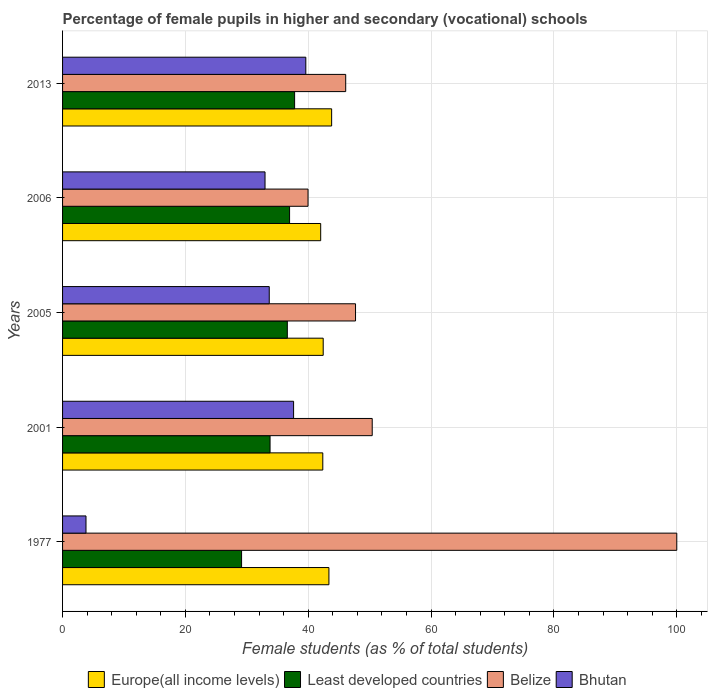Are the number of bars per tick equal to the number of legend labels?
Provide a succinct answer. Yes. What is the label of the 2nd group of bars from the top?
Ensure brevity in your answer.  2006. What is the percentage of female pupils in higher and secondary schools in Bhutan in 2006?
Provide a succinct answer. 32.96. Across all years, what is the maximum percentage of female pupils in higher and secondary schools in Europe(all income levels)?
Your answer should be compact. 43.81. Across all years, what is the minimum percentage of female pupils in higher and secondary schools in Bhutan?
Your response must be concise. 3.81. What is the total percentage of female pupils in higher and secondary schools in Belize in the graph?
Your answer should be compact. 284.17. What is the difference between the percentage of female pupils in higher and secondary schools in Bhutan in 1977 and that in 2006?
Provide a short and direct response. -29.15. What is the difference between the percentage of female pupils in higher and secondary schools in Bhutan in 1977 and the percentage of female pupils in higher and secondary schools in Belize in 2013?
Make the answer very short. -42.28. What is the average percentage of female pupils in higher and secondary schools in Bhutan per year?
Offer a terse response. 29.53. In the year 2013, what is the difference between the percentage of female pupils in higher and secondary schools in Europe(all income levels) and percentage of female pupils in higher and secondary schools in Belize?
Offer a very short reply. -2.29. What is the ratio of the percentage of female pupils in higher and secondary schools in Least developed countries in 1977 to that in 2006?
Ensure brevity in your answer.  0.79. Is the percentage of female pupils in higher and secondary schools in Bhutan in 2005 less than that in 2013?
Your answer should be very brief. Yes. What is the difference between the highest and the second highest percentage of female pupils in higher and secondary schools in Europe(all income levels)?
Offer a very short reply. 0.44. What is the difference between the highest and the lowest percentage of female pupils in higher and secondary schools in Least developed countries?
Your response must be concise. 8.63. Is it the case that in every year, the sum of the percentage of female pupils in higher and secondary schools in Least developed countries and percentage of female pupils in higher and secondary schools in Europe(all income levels) is greater than the sum of percentage of female pupils in higher and secondary schools in Bhutan and percentage of female pupils in higher and secondary schools in Belize?
Keep it short and to the point. No. What does the 1st bar from the top in 1977 represents?
Provide a short and direct response. Bhutan. What does the 3rd bar from the bottom in 2001 represents?
Offer a terse response. Belize. Is it the case that in every year, the sum of the percentage of female pupils in higher and secondary schools in Bhutan and percentage of female pupils in higher and secondary schools in Europe(all income levels) is greater than the percentage of female pupils in higher and secondary schools in Belize?
Offer a terse response. No. How many years are there in the graph?
Your answer should be compact. 5. What is the difference between two consecutive major ticks on the X-axis?
Ensure brevity in your answer.  20. Are the values on the major ticks of X-axis written in scientific E-notation?
Offer a very short reply. No. Does the graph contain any zero values?
Your answer should be very brief. No. Does the graph contain grids?
Offer a terse response. Yes. Where does the legend appear in the graph?
Give a very brief answer. Bottom center. What is the title of the graph?
Your response must be concise. Percentage of female pupils in higher and secondary (vocational) schools. Does "Cambodia" appear as one of the legend labels in the graph?
Make the answer very short. No. What is the label or title of the X-axis?
Your response must be concise. Female students (as % of total students). What is the Female students (as % of total students) of Europe(all income levels) in 1977?
Keep it short and to the point. 43.37. What is the Female students (as % of total students) in Least developed countries in 1977?
Offer a very short reply. 29.15. What is the Female students (as % of total students) in Belize in 1977?
Ensure brevity in your answer.  100. What is the Female students (as % of total students) in Bhutan in 1977?
Ensure brevity in your answer.  3.81. What is the Female students (as % of total students) of Europe(all income levels) in 2001?
Offer a terse response. 42.37. What is the Female students (as % of total students) of Least developed countries in 2001?
Your answer should be very brief. 33.78. What is the Female students (as % of total students) of Belize in 2001?
Offer a terse response. 50.41. What is the Female students (as % of total students) of Bhutan in 2001?
Keep it short and to the point. 37.61. What is the Female students (as % of total students) of Europe(all income levels) in 2005?
Make the answer very short. 42.43. What is the Female students (as % of total students) in Least developed countries in 2005?
Your answer should be very brief. 36.59. What is the Female students (as % of total students) in Belize in 2005?
Offer a terse response. 47.7. What is the Female students (as % of total students) in Bhutan in 2005?
Your answer should be very brief. 33.65. What is the Female students (as % of total students) in Europe(all income levels) in 2006?
Offer a very short reply. 42.03. What is the Female students (as % of total students) in Least developed countries in 2006?
Your response must be concise. 36.96. What is the Female students (as % of total students) in Belize in 2006?
Offer a very short reply. 39.96. What is the Female students (as % of total students) in Bhutan in 2006?
Provide a short and direct response. 32.96. What is the Female students (as % of total students) in Europe(all income levels) in 2013?
Offer a terse response. 43.81. What is the Female students (as % of total students) of Least developed countries in 2013?
Offer a very short reply. 37.78. What is the Female students (as % of total students) in Belize in 2013?
Your answer should be very brief. 46.1. What is the Female students (as % of total students) of Bhutan in 2013?
Provide a short and direct response. 39.6. Across all years, what is the maximum Female students (as % of total students) in Europe(all income levels)?
Ensure brevity in your answer.  43.81. Across all years, what is the maximum Female students (as % of total students) of Least developed countries?
Provide a succinct answer. 37.78. Across all years, what is the maximum Female students (as % of total students) in Bhutan?
Your response must be concise. 39.6. Across all years, what is the minimum Female students (as % of total students) of Europe(all income levels)?
Offer a terse response. 42.03. Across all years, what is the minimum Female students (as % of total students) in Least developed countries?
Your response must be concise. 29.15. Across all years, what is the minimum Female students (as % of total students) in Belize?
Your answer should be compact. 39.96. Across all years, what is the minimum Female students (as % of total students) of Bhutan?
Give a very brief answer. 3.81. What is the total Female students (as % of total students) in Europe(all income levels) in the graph?
Your response must be concise. 214. What is the total Female students (as % of total students) in Least developed countries in the graph?
Ensure brevity in your answer.  174.26. What is the total Female students (as % of total students) of Belize in the graph?
Provide a short and direct response. 284.17. What is the total Female students (as % of total students) in Bhutan in the graph?
Make the answer very short. 147.65. What is the difference between the Female students (as % of total students) in Least developed countries in 1977 and that in 2001?
Provide a succinct answer. -4.64. What is the difference between the Female students (as % of total students) in Belize in 1977 and that in 2001?
Ensure brevity in your answer.  49.59. What is the difference between the Female students (as % of total students) of Bhutan in 1977 and that in 2001?
Your answer should be compact. -33.8. What is the difference between the Female students (as % of total students) in Europe(all income levels) in 1977 and that in 2005?
Your response must be concise. 0.93. What is the difference between the Female students (as % of total students) of Least developed countries in 1977 and that in 2005?
Provide a short and direct response. -7.45. What is the difference between the Female students (as % of total students) of Belize in 1977 and that in 2005?
Make the answer very short. 52.3. What is the difference between the Female students (as % of total students) of Bhutan in 1977 and that in 2005?
Your response must be concise. -29.84. What is the difference between the Female students (as % of total students) in Europe(all income levels) in 1977 and that in 2006?
Offer a very short reply. 1.34. What is the difference between the Female students (as % of total students) of Least developed countries in 1977 and that in 2006?
Ensure brevity in your answer.  -7.81. What is the difference between the Female students (as % of total students) in Belize in 1977 and that in 2006?
Ensure brevity in your answer.  60.04. What is the difference between the Female students (as % of total students) of Bhutan in 1977 and that in 2006?
Make the answer very short. -29.15. What is the difference between the Female students (as % of total students) of Europe(all income levels) in 1977 and that in 2013?
Make the answer very short. -0.44. What is the difference between the Female students (as % of total students) in Least developed countries in 1977 and that in 2013?
Offer a very short reply. -8.63. What is the difference between the Female students (as % of total students) in Belize in 1977 and that in 2013?
Your response must be concise. 53.9. What is the difference between the Female students (as % of total students) of Bhutan in 1977 and that in 2013?
Make the answer very short. -35.79. What is the difference between the Female students (as % of total students) of Europe(all income levels) in 2001 and that in 2005?
Provide a succinct answer. -0.07. What is the difference between the Female students (as % of total students) in Least developed countries in 2001 and that in 2005?
Keep it short and to the point. -2.81. What is the difference between the Female students (as % of total students) of Belize in 2001 and that in 2005?
Offer a terse response. 2.72. What is the difference between the Female students (as % of total students) of Bhutan in 2001 and that in 2005?
Your answer should be compact. 3.96. What is the difference between the Female students (as % of total students) of Europe(all income levels) in 2001 and that in 2006?
Make the answer very short. 0.34. What is the difference between the Female students (as % of total students) of Least developed countries in 2001 and that in 2006?
Provide a succinct answer. -3.18. What is the difference between the Female students (as % of total students) in Belize in 2001 and that in 2006?
Your answer should be very brief. 10.45. What is the difference between the Female students (as % of total students) of Bhutan in 2001 and that in 2006?
Offer a terse response. 4.65. What is the difference between the Female students (as % of total students) of Europe(all income levels) in 2001 and that in 2013?
Provide a short and direct response. -1.44. What is the difference between the Female students (as % of total students) in Least developed countries in 2001 and that in 2013?
Give a very brief answer. -4. What is the difference between the Female students (as % of total students) of Belize in 2001 and that in 2013?
Your response must be concise. 4.32. What is the difference between the Female students (as % of total students) of Bhutan in 2001 and that in 2013?
Ensure brevity in your answer.  -1.99. What is the difference between the Female students (as % of total students) of Europe(all income levels) in 2005 and that in 2006?
Provide a short and direct response. 0.41. What is the difference between the Female students (as % of total students) of Least developed countries in 2005 and that in 2006?
Give a very brief answer. -0.37. What is the difference between the Female students (as % of total students) of Belize in 2005 and that in 2006?
Your answer should be very brief. 7.74. What is the difference between the Female students (as % of total students) of Bhutan in 2005 and that in 2006?
Provide a succinct answer. 0.69. What is the difference between the Female students (as % of total students) of Europe(all income levels) in 2005 and that in 2013?
Give a very brief answer. -1.37. What is the difference between the Female students (as % of total students) of Least developed countries in 2005 and that in 2013?
Your answer should be compact. -1.19. What is the difference between the Female students (as % of total students) of Belize in 2005 and that in 2013?
Your answer should be very brief. 1.6. What is the difference between the Female students (as % of total students) in Bhutan in 2005 and that in 2013?
Provide a short and direct response. -5.95. What is the difference between the Female students (as % of total students) in Europe(all income levels) in 2006 and that in 2013?
Your answer should be very brief. -1.78. What is the difference between the Female students (as % of total students) of Least developed countries in 2006 and that in 2013?
Make the answer very short. -0.82. What is the difference between the Female students (as % of total students) in Belize in 2006 and that in 2013?
Your response must be concise. -6.13. What is the difference between the Female students (as % of total students) in Bhutan in 2006 and that in 2013?
Offer a terse response. -6.64. What is the difference between the Female students (as % of total students) of Europe(all income levels) in 1977 and the Female students (as % of total students) of Least developed countries in 2001?
Provide a short and direct response. 9.58. What is the difference between the Female students (as % of total students) in Europe(all income levels) in 1977 and the Female students (as % of total students) in Belize in 2001?
Give a very brief answer. -7.05. What is the difference between the Female students (as % of total students) in Europe(all income levels) in 1977 and the Female students (as % of total students) in Bhutan in 2001?
Make the answer very short. 5.75. What is the difference between the Female students (as % of total students) of Least developed countries in 1977 and the Female students (as % of total students) of Belize in 2001?
Offer a terse response. -21.27. What is the difference between the Female students (as % of total students) of Least developed countries in 1977 and the Female students (as % of total students) of Bhutan in 2001?
Your answer should be compact. -8.47. What is the difference between the Female students (as % of total students) of Belize in 1977 and the Female students (as % of total students) of Bhutan in 2001?
Ensure brevity in your answer.  62.39. What is the difference between the Female students (as % of total students) of Europe(all income levels) in 1977 and the Female students (as % of total students) of Least developed countries in 2005?
Your answer should be very brief. 6.77. What is the difference between the Female students (as % of total students) in Europe(all income levels) in 1977 and the Female students (as % of total students) in Belize in 2005?
Your answer should be compact. -4.33. What is the difference between the Female students (as % of total students) of Europe(all income levels) in 1977 and the Female students (as % of total students) of Bhutan in 2005?
Give a very brief answer. 9.72. What is the difference between the Female students (as % of total students) of Least developed countries in 1977 and the Female students (as % of total students) of Belize in 2005?
Provide a short and direct response. -18.55. What is the difference between the Female students (as % of total students) in Least developed countries in 1977 and the Female students (as % of total students) in Bhutan in 2005?
Give a very brief answer. -4.51. What is the difference between the Female students (as % of total students) in Belize in 1977 and the Female students (as % of total students) in Bhutan in 2005?
Keep it short and to the point. 66.35. What is the difference between the Female students (as % of total students) of Europe(all income levels) in 1977 and the Female students (as % of total students) of Least developed countries in 2006?
Keep it short and to the point. 6.41. What is the difference between the Female students (as % of total students) of Europe(all income levels) in 1977 and the Female students (as % of total students) of Belize in 2006?
Your answer should be compact. 3.4. What is the difference between the Female students (as % of total students) in Europe(all income levels) in 1977 and the Female students (as % of total students) in Bhutan in 2006?
Ensure brevity in your answer.  10.4. What is the difference between the Female students (as % of total students) in Least developed countries in 1977 and the Female students (as % of total students) in Belize in 2006?
Your answer should be very brief. -10.82. What is the difference between the Female students (as % of total students) in Least developed countries in 1977 and the Female students (as % of total students) in Bhutan in 2006?
Give a very brief answer. -3.82. What is the difference between the Female students (as % of total students) of Belize in 1977 and the Female students (as % of total students) of Bhutan in 2006?
Provide a succinct answer. 67.04. What is the difference between the Female students (as % of total students) of Europe(all income levels) in 1977 and the Female students (as % of total students) of Least developed countries in 2013?
Ensure brevity in your answer.  5.59. What is the difference between the Female students (as % of total students) in Europe(all income levels) in 1977 and the Female students (as % of total students) in Belize in 2013?
Your answer should be very brief. -2.73. What is the difference between the Female students (as % of total students) of Europe(all income levels) in 1977 and the Female students (as % of total students) of Bhutan in 2013?
Provide a short and direct response. 3.76. What is the difference between the Female students (as % of total students) of Least developed countries in 1977 and the Female students (as % of total students) of Belize in 2013?
Make the answer very short. -16.95. What is the difference between the Female students (as % of total students) of Least developed countries in 1977 and the Female students (as % of total students) of Bhutan in 2013?
Provide a succinct answer. -10.46. What is the difference between the Female students (as % of total students) in Belize in 1977 and the Female students (as % of total students) in Bhutan in 2013?
Make the answer very short. 60.4. What is the difference between the Female students (as % of total students) in Europe(all income levels) in 2001 and the Female students (as % of total students) in Least developed countries in 2005?
Give a very brief answer. 5.77. What is the difference between the Female students (as % of total students) of Europe(all income levels) in 2001 and the Female students (as % of total students) of Belize in 2005?
Offer a terse response. -5.33. What is the difference between the Female students (as % of total students) of Europe(all income levels) in 2001 and the Female students (as % of total students) of Bhutan in 2005?
Your answer should be very brief. 8.72. What is the difference between the Female students (as % of total students) of Least developed countries in 2001 and the Female students (as % of total students) of Belize in 2005?
Provide a succinct answer. -13.92. What is the difference between the Female students (as % of total students) in Least developed countries in 2001 and the Female students (as % of total students) in Bhutan in 2005?
Your response must be concise. 0.13. What is the difference between the Female students (as % of total students) in Belize in 2001 and the Female students (as % of total students) in Bhutan in 2005?
Keep it short and to the point. 16.76. What is the difference between the Female students (as % of total students) in Europe(all income levels) in 2001 and the Female students (as % of total students) in Least developed countries in 2006?
Give a very brief answer. 5.41. What is the difference between the Female students (as % of total students) in Europe(all income levels) in 2001 and the Female students (as % of total students) in Belize in 2006?
Your response must be concise. 2.41. What is the difference between the Female students (as % of total students) in Europe(all income levels) in 2001 and the Female students (as % of total students) in Bhutan in 2006?
Keep it short and to the point. 9.41. What is the difference between the Female students (as % of total students) in Least developed countries in 2001 and the Female students (as % of total students) in Belize in 2006?
Offer a very short reply. -6.18. What is the difference between the Female students (as % of total students) of Least developed countries in 2001 and the Female students (as % of total students) of Bhutan in 2006?
Your response must be concise. 0.82. What is the difference between the Female students (as % of total students) in Belize in 2001 and the Female students (as % of total students) in Bhutan in 2006?
Your answer should be very brief. 17.45. What is the difference between the Female students (as % of total students) of Europe(all income levels) in 2001 and the Female students (as % of total students) of Least developed countries in 2013?
Your response must be concise. 4.59. What is the difference between the Female students (as % of total students) in Europe(all income levels) in 2001 and the Female students (as % of total students) in Belize in 2013?
Give a very brief answer. -3.73. What is the difference between the Female students (as % of total students) of Europe(all income levels) in 2001 and the Female students (as % of total students) of Bhutan in 2013?
Your answer should be very brief. 2.76. What is the difference between the Female students (as % of total students) in Least developed countries in 2001 and the Female students (as % of total students) in Belize in 2013?
Offer a very short reply. -12.31. What is the difference between the Female students (as % of total students) in Least developed countries in 2001 and the Female students (as % of total students) in Bhutan in 2013?
Offer a very short reply. -5.82. What is the difference between the Female students (as % of total students) of Belize in 2001 and the Female students (as % of total students) of Bhutan in 2013?
Ensure brevity in your answer.  10.81. What is the difference between the Female students (as % of total students) in Europe(all income levels) in 2005 and the Female students (as % of total students) in Least developed countries in 2006?
Provide a succinct answer. 5.47. What is the difference between the Female students (as % of total students) in Europe(all income levels) in 2005 and the Female students (as % of total students) in Belize in 2006?
Ensure brevity in your answer.  2.47. What is the difference between the Female students (as % of total students) in Europe(all income levels) in 2005 and the Female students (as % of total students) in Bhutan in 2006?
Your answer should be compact. 9.47. What is the difference between the Female students (as % of total students) in Least developed countries in 2005 and the Female students (as % of total students) in Belize in 2006?
Make the answer very short. -3.37. What is the difference between the Female students (as % of total students) in Least developed countries in 2005 and the Female students (as % of total students) in Bhutan in 2006?
Provide a short and direct response. 3.63. What is the difference between the Female students (as % of total students) in Belize in 2005 and the Female students (as % of total students) in Bhutan in 2006?
Make the answer very short. 14.74. What is the difference between the Female students (as % of total students) in Europe(all income levels) in 2005 and the Female students (as % of total students) in Least developed countries in 2013?
Offer a terse response. 4.65. What is the difference between the Female students (as % of total students) in Europe(all income levels) in 2005 and the Female students (as % of total students) in Belize in 2013?
Your answer should be very brief. -3.66. What is the difference between the Female students (as % of total students) of Europe(all income levels) in 2005 and the Female students (as % of total students) of Bhutan in 2013?
Provide a succinct answer. 2.83. What is the difference between the Female students (as % of total students) in Least developed countries in 2005 and the Female students (as % of total students) in Belize in 2013?
Your response must be concise. -9.5. What is the difference between the Female students (as % of total students) in Least developed countries in 2005 and the Female students (as % of total students) in Bhutan in 2013?
Your answer should be very brief. -3.01. What is the difference between the Female students (as % of total students) of Belize in 2005 and the Female students (as % of total students) of Bhutan in 2013?
Your answer should be very brief. 8.09. What is the difference between the Female students (as % of total students) in Europe(all income levels) in 2006 and the Female students (as % of total students) in Least developed countries in 2013?
Your answer should be compact. 4.25. What is the difference between the Female students (as % of total students) in Europe(all income levels) in 2006 and the Female students (as % of total students) in Belize in 2013?
Give a very brief answer. -4.07. What is the difference between the Female students (as % of total students) in Europe(all income levels) in 2006 and the Female students (as % of total students) in Bhutan in 2013?
Your response must be concise. 2.42. What is the difference between the Female students (as % of total students) in Least developed countries in 2006 and the Female students (as % of total students) in Belize in 2013?
Make the answer very short. -9.14. What is the difference between the Female students (as % of total students) of Least developed countries in 2006 and the Female students (as % of total students) of Bhutan in 2013?
Make the answer very short. -2.64. What is the difference between the Female students (as % of total students) of Belize in 2006 and the Female students (as % of total students) of Bhutan in 2013?
Offer a very short reply. 0.36. What is the average Female students (as % of total students) of Europe(all income levels) per year?
Provide a succinct answer. 42.8. What is the average Female students (as % of total students) in Least developed countries per year?
Ensure brevity in your answer.  34.85. What is the average Female students (as % of total students) in Belize per year?
Offer a terse response. 56.83. What is the average Female students (as % of total students) in Bhutan per year?
Provide a succinct answer. 29.53. In the year 1977, what is the difference between the Female students (as % of total students) in Europe(all income levels) and Female students (as % of total students) in Least developed countries?
Keep it short and to the point. 14.22. In the year 1977, what is the difference between the Female students (as % of total students) of Europe(all income levels) and Female students (as % of total students) of Belize?
Your answer should be very brief. -56.63. In the year 1977, what is the difference between the Female students (as % of total students) of Europe(all income levels) and Female students (as % of total students) of Bhutan?
Provide a short and direct response. 39.55. In the year 1977, what is the difference between the Female students (as % of total students) of Least developed countries and Female students (as % of total students) of Belize?
Offer a very short reply. -70.85. In the year 1977, what is the difference between the Female students (as % of total students) of Least developed countries and Female students (as % of total students) of Bhutan?
Offer a very short reply. 25.33. In the year 1977, what is the difference between the Female students (as % of total students) of Belize and Female students (as % of total students) of Bhutan?
Your answer should be compact. 96.19. In the year 2001, what is the difference between the Female students (as % of total students) in Europe(all income levels) and Female students (as % of total students) in Least developed countries?
Your response must be concise. 8.59. In the year 2001, what is the difference between the Female students (as % of total students) of Europe(all income levels) and Female students (as % of total students) of Belize?
Give a very brief answer. -8.05. In the year 2001, what is the difference between the Female students (as % of total students) in Europe(all income levels) and Female students (as % of total students) in Bhutan?
Your answer should be very brief. 4.76. In the year 2001, what is the difference between the Female students (as % of total students) in Least developed countries and Female students (as % of total students) in Belize?
Provide a succinct answer. -16.63. In the year 2001, what is the difference between the Female students (as % of total students) of Least developed countries and Female students (as % of total students) of Bhutan?
Keep it short and to the point. -3.83. In the year 2001, what is the difference between the Female students (as % of total students) in Belize and Female students (as % of total students) in Bhutan?
Offer a terse response. 12.8. In the year 2005, what is the difference between the Female students (as % of total students) of Europe(all income levels) and Female students (as % of total students) of Least developed countries?
Provide a succinct answer. 5.84. In the year 2005, what is the difference between the Female students (as % of total students) of Europe(all income levels) and Female students (as % of total students) of Belize?
Offer a very short reply. -5.26. In the year 2005, what is the difference between the Female students (as % of total students) of Europe(all income levels) and Female students (as % of total students) of Bhutan?
Make the answer very short. 8.78. In the year 2005, what is the difference between the Female students (as % of total students) in Least developed countries and Female students (as % of total students) in Belize?
Ensure brevity in your answer.  -11.1. In the year 2005, what is the difference between the Female students (as % of total students) in Least developed countries and Female students (as % of total students) in Bhutan?
Your answer should be very brief. 2.94. In the year 2005, what is the difference between the Female students (as % of total students) in Belize and Female students (as % of total students) in Bhutan?
Offer a terse response. 14.05. In the year 2006, what is the difference between the Female students (as % of total students) of Europe(all income levels) and Female students (as % of total students) of Least developed countries?
Keep it short and to the point. 5.07. In the year 2006, what is the difference between the Female students (as % of total students) of Europe(all income levels) and Female students (as % of total students) of Belize?
Keep it short and to the point. 2.06. In the year 2006, what is the difference between the Female students (as % of total students) in Europe(all income levels) and Female students (as % of total students) in Bhutan?
Your response must be concise. 9.06. In the year 2006, what is the difference between the Female students (as % of total students) in Least developed countries and Female students (as % of total students) in Belize?
Your answer should be compact. -3. In the year 2006, what is the difference between the Female students (as % of total students) of Least developed countries and Female students (as % of total students) of Bhutan?
Provide a short and direct response. 4. In the year 2006, what is the difference between the Female students (as % of total students) in Belize and Female students (as % of total students) in Bhutan?
Your response must be concise. 7. In the year 2013, what is the difference between the Female students (as % of total students) of Europe(all income levels) and Female students (as % of total students) of Least developed countries?
Offer a very short reply. 6.03. In the year 2013, what is the difference between the Female students (as % of total students) in Europe(all income levels) and Female students (as % of total students) in Belize?
Make the answer very short. -2.29. In the year 2013, what is the difference between the Female students (as % of total students) in Europe(all income levels) and Female students (as % of total students) in Bhutan?
Provide a succinct answer. 4.2. In the year 2013, what is the difference between the Female students (as % of total students) of Least developed countries and Female students (as % of total students) of Belize?
Keep it short and to the point. -8.32. In the year 2013, what is the difference between the Female students (as % of total students) in Least developed countries and Female students (as % of total students) in Bhutan?
Ensure brevity in your answer.  -1.82. In the year 2013, what is the difference between the Female students (as % of total students) in Belize and Female students (as % of total students) in Bhutan?
Provide a succinct answer. 6.49. What is the ratio of the Female students (as % of total students) of Europe(all income levels) in 1977 to that in 2001?
Provide a short and direct response. 1.02. What is the ratio of the Female students (as % of total students) in Least developed countries in 1977 to that in 2001?
Your response must be concise. 0.86. What is the ratio of the Female students (as % of total students) of Belize in 1977 to that in 2001?
Your answer should be compact. 1.98. What is the ratio of the Female students (as % of total students) of Bhutan in 1977 to that in 2001?
Make the answer very short. 0.1. What is the ratio of the Female students (as % of total students) of Europe(all income levels) in 1977 to that in 2005?
Keep it short and to the point. 1.02. What is the ratio of the Female students (as % of total students) in Least developed countries in 1977 to that in 2005?
Offer a terse response. 0.8. What is the ratio of the Female students (as % of total students) of Belize in 1977 to that in 2005?
Keep it short and to the point. 2.1. What is the ratio of the Female students (as % of total students) in Bhutan in 1977 to that in 2005?
Offer a very short reply. 0.11. What is the ratio of the Female students (as % of total students) of Europe(all income levels) in 1977 to that in 2006?
Ensure brevity in your answer.  1.03. What is the ratio of the Female students (as % of total students) in Least developed countries in 1977 to that in 2006?
Your answer should be very brief. 0.79. What is the ratio of the Female students (as % of total students) of Belize in 1977 to that in 2006?
Provide a succinct answer. 2.5. What is the ratio of the Female students (as % of total students) in Bhutan in 1977 to that in 2006?
Your answer should be very brief. 0.12. What is the ratio of the Female students (as % of total students) of Europe(all income levels) in 1977 to that in 2013?
Give a very brief answer. 0.99. What is the ratio of the Female students (as % of total students) in Least developed countries in 1977 to that in 2013?
Offer a very short reply. 0.77. What is the ratio of the Female students (as % of total students) in Belize in 1977 to that in 2013?
Give a very brief answer. 2.17. What is the ratio of the Female students (as % of total students) of Bhutan in 1977 to that in 2013?
Ensure brevity in your answer.  0.1. What is the ratio of the Female students (as % of total students) of Least developed countries in 2001 to that in 2005?
Make the answer very short. 0.92. What is the ratio of the Female students (as % of total students) in Belize in 2001 to that in 2005?
Your response must be concise. 1.06. What is the ratio of the Female students (as % of total students) of Bhutan in 2001 to that in 2005?
Your response must be concise. 1.12. What is the ratio of the Female students (as % of total students) in Europe(all income levels) in 2001 to that in 2006?
Keep it short and to the point. 1.01. What is the ratio of the Female students (as % of total students) in Least developed countries in 2001 to that in 2006?
Give a very brief answer. 0.91. What is the ratio of the Female students (as % of total students) of Belize in 2001 to that in 2006?
Give a very brief answer. 1.26. What is the ratio of the Female students (as % of total students) in Bhutan in 2001 to that in 2006?
Your response must be concise. 1.14. What is the ratio of the Female students (as % of total students) of Europe(all income levels) in 2001 to that in 2013?
Provide a short and direct response. 0.97. What is the ratio of the Female students (as % of total students) in Least developed countries in 2001 to that in 2013?
Provide a short and direct response. 0.89. What is the ratio of the Female students (as % of total students) of Belize in 2001 to that in 2013?
Your response must be concise. 1.09. What is the ratio of the Female students (as % of total students) in Bhutan in 2001 to that in 2013?
Make the answer very short. 0.95. What is the ratio of the Female students (as % of total students) in Europe(all income levels) in 2005 to that in 2006?
Provide a succinct answer. 1.01. What is the ratio of the Female students (as % of total students) of Belize in 2005 to that in 2006?
Your answer should be compact. 1.19. What is the ratio of the Female students (as % of total students) of Bhutan in 2005 to that in 2006?
Ensure brevity in your answer.  1.02. What is the ratio of the Female students (as % of total students) of Europe(all income levels) in 2005 to that in 2013?
Provide a short and direct response. 0.97. What is the ratio of the Female students (as % of total students) of Least developed countries in 2005 to that in 2013?
Keep it short and to the point. 0.97. What is the ratio of the Female students (as % of total students) in Belize in 2005 to that in 2013?
Provide a short and direct response. 1.03. What is the ratio of the Female students (as % of total students) of Bhutan in 2005 to that in 2013?
Give a very brief answer. 0.85. What is the ratio of the Female students (as % of total students) of Europe(all income levels) in 2006 to that in 2013?
Ensure brevity in your answer.  0.96. What is the ratio of the Female students (as % of total students) in Least developed countries in 2006 to that in 2013?
Your answer should be compact. 0.98. What is the ratio of the Female students (as % of total students) of Belize in 2006 to that in 2013?
Provide a succinct answer. 0.87. What is the ratio of the Female students (as % of total students) of Bhutan in 2006 to that in 2013?
Your response must be concise. 0.83. What is the difference between the highest and the second highest Female students (as % of total students) of Europe(all income levels)?
Your answer should be very brief. 0.44. What is the difference between the highest and the second highest Female students (as % of total students) in Least developed countries?
Provide a succinct answer. 0.82. What is the difference between the highest and the second highest Female students (as % of total students) of Belize?
Provide a short and direct response. 49.59. What is the difference between the highest and the second highest Female students (as % of total students) of Bhutan?
Offer a terse response. 1.99. What is the difference between the highest and the lowest Female students (as % of total students) of Europe(all income levels)?
Offer a very short reply. 1.78. What is the difference between the highest and the lowest Female students (as % of total students) in Least developed countries?
Your answer should be compact. 8.63. What is the difference between the highest and the lowest Female students (as % of total students) in Belize?
Provide a short and direct response. 60.04. What is the difference between the highest and the lowest Female students (as % of total students) in Bhutan?
Your answer should be compact. 35.79. 